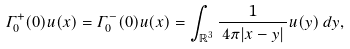<formula> <loc_0><loc_0><loc_500><loc_500>\varGamma _ { 0 } ^ { + } ( 0 ) u ( x ) = \varGamma _ { 0 } ^ { - } ( 0 ) u ( x ) = \int _ { { \mathbb { R } } ^ { 3 } } \frac { 1 } { \, 4 \pi | x - y | \, } u ( y ) \, d y ,</formula> 